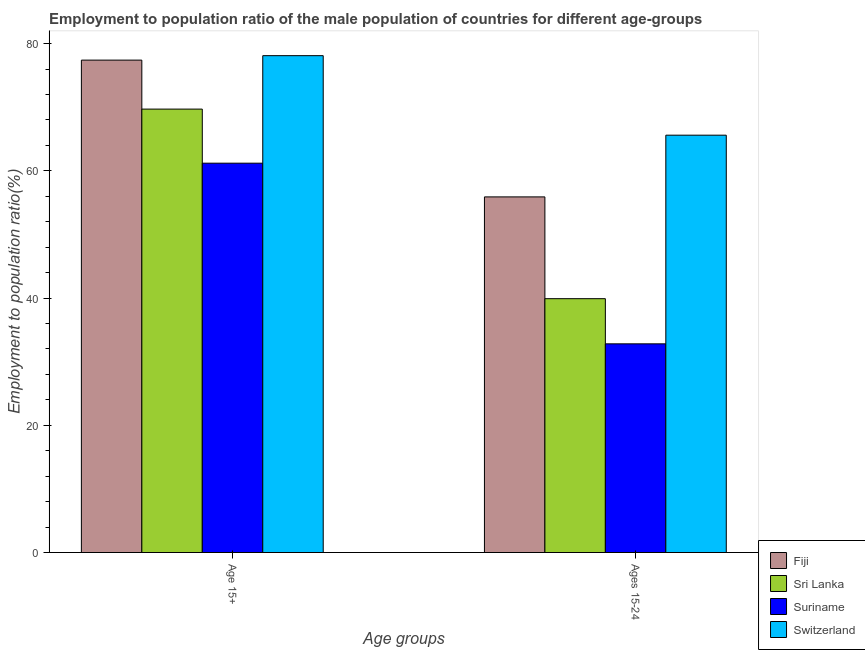How many different coloured bars are there?
Ensure brevity in your answer.  4. How many groups of bars are there?
Your answer should be very brief. 2. Are the number of bars per tick equal to the number of legend labels?
Give a very brief answer. Yes. Are the number of bars on each tick of the X-axis equal?
Give a very brief answer. Yes. What is the label of the 2nd group of bars from the left?
Offer a very short reply. Ages 15-24. What is the employment to population ratio(age 15-24) in Switzerland?
Keep it short and to the point. 65.6. Across all countries, what is the maximum employment to population ratio(age 15-24)?
Make the answer very short. 65.6. Across all countries, what is the minimum employment to population ratio(age 15-24)?
Provide a succinct answer. 32.8. In which country was the employment to population ratio(age 15-24) maximum?
Keep it short and to the point. Switzerland. In which country was the employment to population ratio(age 15+) minimum?
Ensure brevity in your answer.  Suriname. What is the total employment to population ratio(age 15-24) in the graph?
Offer a terse response. 194.2. What is the difference between the employment to population ratio(age 15+) in Suriname and that in Sri Lanka?
Your answer should be compact. -8.5. What is the difference between the employment to population ratio(age 15-24) in Fiji and the employment to population ratio(age 15+) in Suriname?
Your answer should be compact. -5.3. What is the average employment to population ratio(age 15-24) per country?
Your answer should be very brief. 48.55. What is the difference between the employment to population ratio(age 15+) and employment to population ratio(age 15-24) in Sri Lanka?
Keep it short and to the point. 29.8. In how many countries, is the employment to population ratio(age 15+) greater than 72 %?
Give a very brief answer. 2. Is the employment to population ratio(age 15+) in Switzerland less than that in Fiji?
Offer a terse response. No. In how many countries, is the employment to population ratio(age 15-24) greater than the average employment to population ratio(age 15-24) taken over all countries?
Keep it short and to the point. 2. What does the 4th bar from the left in Age 15+ represents?
Make the answer very short. Switzerland. What does the 3rd bar from the right in Ages 15-24 represents?
Keep it short and to the point. Sri Lanka. How many countries are there in the graph?
Provide a succinct answer. 4. Are the values on the major ticks of Y-axis written in scientific E-notation?
Ensure brevity in your answer.  No. Does the graph contain any zero values?
Keep it short and to the point. No. What is the title of the graph?
Make the answer very short. Employment to population ratio of the male population of countries for different age-groups. What is the label or title of the X-axis?
Make the answer very short. Age groups. What is the Employment to population ratio(%) of Fiji in Age 15+?
Provide a short and direct response. 77.4. What is the Employment to population ratio(%) in Sri Lanka in Age 15+?
Make the answer very short. 69.7. What is the Employment to population ratio(%) in Suriname in Age 15+?
Give a very brief answer. 61.2. What is the Employment to population ratio(%) of Switzerland in Age 15+?
Your answer should be very brief. 78.1. What is the Employment to population ratio(%) of Fiji in Ages 15-24?
Your answer should be compact. 55.9. What is the Employment to population ratio(%) in Sri Lanka in Ages 15-24?
Offer a very short reply. 39.9. What is the Employment to population ratio(%) in Suriname in Ages 15-24?
Your answer should be very brief. 32.8. What is the Employment to population ratio(%) of Switzerland in Ages 15-24?
Your answer should be very brief. 65.6. Across all Age groups, what is the maximum Employment to population ratio(%) in Fiji?
Give a very brief answer. 77.4. Across all Age groups, what is the maximum Employment to population ratio(%) of Sri Lanka?
Keep it short and to the point. 69.7. Across all Age groups, what is the maximum Employment to population ratio(%) in Suriname?
Make the answer very short. 61.2. Across all Age groups, what is the maximum Employment to population ratio(%) of Switzerland?
Your answer should be compact. 78.1. Across all Age groups, what is the minimum Employment to population ratio(%) of Fiji?
Offer a very short reply. 55.9. Across all Age groups, what is the minimum Employment to population ratio(%) in Sri Lanka?
Your answer should be compact. 39.9. Across all Age groups, what is the minimum Employment to population ratio(%) of Suriname?
Your answer should be compact. 32.8. Across all Age groups, what is the minimum Employment to population ratio(%) of Switzerland?
Keep it short and to the point. 65.6. What is the total Employment to population ratio(%) in Fiji in the graph?
Provide a succinct answer. 133.3. What is the total Employment to population ratio(%) of Sri Lanka in the graph?
Offer a very short reply. 109.6. What is the total Employment to population ratio(%) in Suriname in the graph?
Give a very brief answer. 94. What is the total Employment to population ratio(%) of Switzerland in the graph?
Your answer should be compact. 143.7. What is the difference between the Employment to population ratio(%) of Fiji in Age 15+ and that in Ages 15-24?
Ensure brevity in your answer.  21.5. What is the difference between the Employment to population ratio(%) in Sri Lanka in Age 15+ and that in Ages 15-24?
Give a very brief answer. 29.8. What is the difference between the Employment to population ratio(%) in Suriname in Age 15+ and that in Ages 15-24?
Ensure brevity in your answer.  28.4. What is the difference between the Employment to population ratio(%) of Fiji in Age 15+ and the Employment to population ratio(%) of Sri Lanka in Ages 15-24?
Keep it short and to the point. 37.5. What is the difference between the Employment to population ratio(%) in Fiji in Age 15+ and the Employment to population ratio(%) in Suriname in Ages 15-24?
Your response must be concise. 44.6. What is the difference between the Employment to population ratio(%) of Sri Lanka in Age 15+ and the Employment to population ratio(%) of Suriname in Ages 15-24?
Your answer should be compact. 36.9. What is the difference between the Employment to population ratio(%) of Suriname in Age 15+ and the Employment to population ratio(%) of Switzerland in Ages 15-24?
Offer a terse response. -4.4. What is the average Employment to population ratio(%) of Fiji per Age groups?
Provide a succinct answer. 66.65. What is the average Employment to population ratio(%) of Sri Lanka per Age groups?
Provide a short and direct response. 54.8. What is the average Employment to population ratio(%) in Suriname per Age groups?
Your answer should be very brief. 47. What is the average Employment to population ratio(%) of Switzerland per Age groups?
Give a very brief answer. 71.85. What is the difference between the Employment to population ratio(%) in Fiji and Employment to population ratio(%) in Sri Lanka in Age 15+?
Make the answer very short. 7.7. What is the difference between the Employment to population ratio(%) in Fiji and Employment to population ratio(%) in Suriname in Age 15+?
Ensure brevity in your answer.  16.2. What is the difference between the Employment to population ratio(%) of Fiji and Employment to population ratio(%) of Switzerland in Age 15+?
Your answer should be compact. -0.7. What is the difference between the Employment to population ratio(%) of Sri Lanka and Employment to population ratio(%) of Switzerland in Age 15+?
Offer a very short reply. -8.4. What is the difference between the Employment to population ratio(%) of Suriname and Employment to population ratio(%) of Switzerland in Age 15+?
Provide a short and direct response. -16.9. What is the difference between the Employment to population ratio(%) of Fiji and Employment to population ratio(%) of Sri Lanka in Ages 15-24?
Your response must be concise. 16. What is the difference between the Employment to population ratio(%) of Fiji and Employment to population ratio(%) of Suriname in Ages 15-24?
Your response must be concise. 23.1. What is the difference between the Employment to population ratio(%) of Sri Lanka and Employment to population ratio(%) of Suriname in Ages 15-24?
Offer a terse response. 7.1. What is the difference between the Employment to population ratio(%) of Sri Lanka and Employment to population ratio(%) of Switzerland in Ages 15-24?
Keep it short and to the point. -25.7. What is the difference between the Employment to population ratio(%) in Suriname and Employment to population ratio(%) in Switzerland in Ages 15-24?
Offer a terse response. -32.8. What is the ratio of the Employment to population ratio(%) in Fiji in Age 15+ to that in Ages 15-24?
Give a very brief answer. 1.38. What is the ratio of the Employment to population ratio(%) in Sri Lanka in Age 15+ to that in Ages 15-24?
Ensure brevity in your answer.  1.75. What is the ratio of the Employment to population ratio(%) in Suriname in Age 15+ to that in Ages 15-24?
Offer a terse response. 1.87. What is the ratio of the Employment to population ratio(%) in Switzerland in Age 15+ to that in Ages 15-24?
Give a very brief answer. 1.19. What is the difference between the highest and the second highest Employment to population ratio(%) of Sri Lanka?
Give a very brief answer. 29.8. What is the difference between the highest and the second highest Employment to population ratio(%) in Suriname?
Offer a terse response. 28.4. What is the difference between the highest and the second highest Employment to population ratio(%) of Switzerland?
Make the answer very short. 12.5. What is the difference between the highest and the lowest Employment to population ratio(%) in Fiji?
Ensure brevity in your answer.  21.5. What is the difference between the highest and the lowest Employment to population ratio(%) in Sri Lanka?
Ensure brevity in your answer.  29.8. What is the difference between the highest and the lowest Employment to population ratio(%) in Suriname?
Offer a terse response. 28.4. What is the difference between the highest and the lowest Employment to population ratio(%) in Switzerland?
Ensure brevity in your answer.  12.5. 